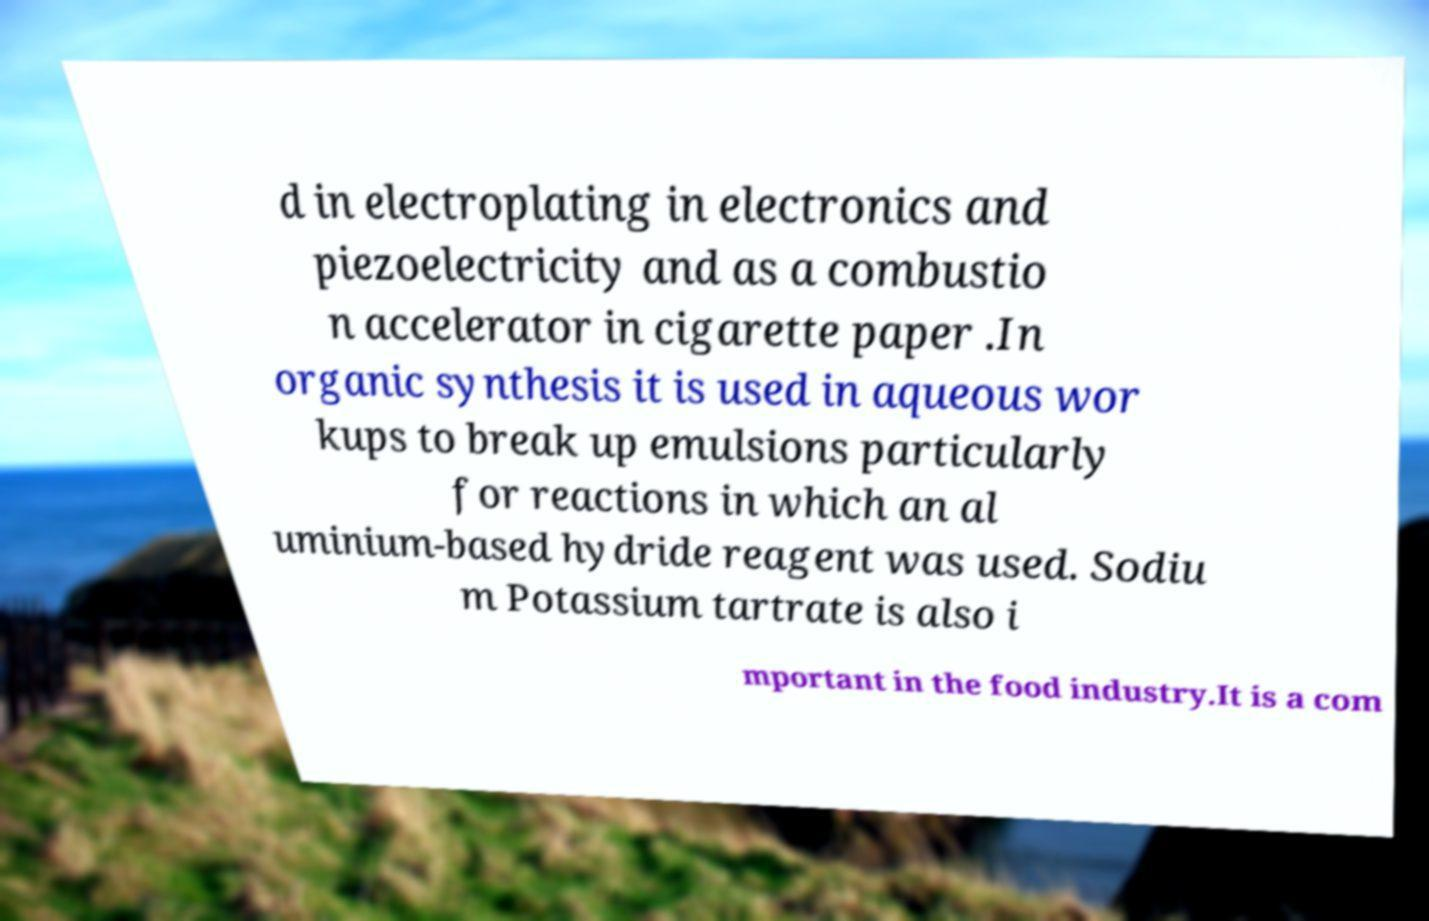Please read and relay the text visible in this image. What does it say? d in electroplating in electronics and piezoelectricity and as a combustio n accelerator in cigarette paper .In organic synthesis it is used in aqueous wor kups to break up emulsions particularly for reactions in which an al uminium-based hydride reagent was used. Sodiu m Potassium tartrate is also i mportant in the food industry.It is a com 